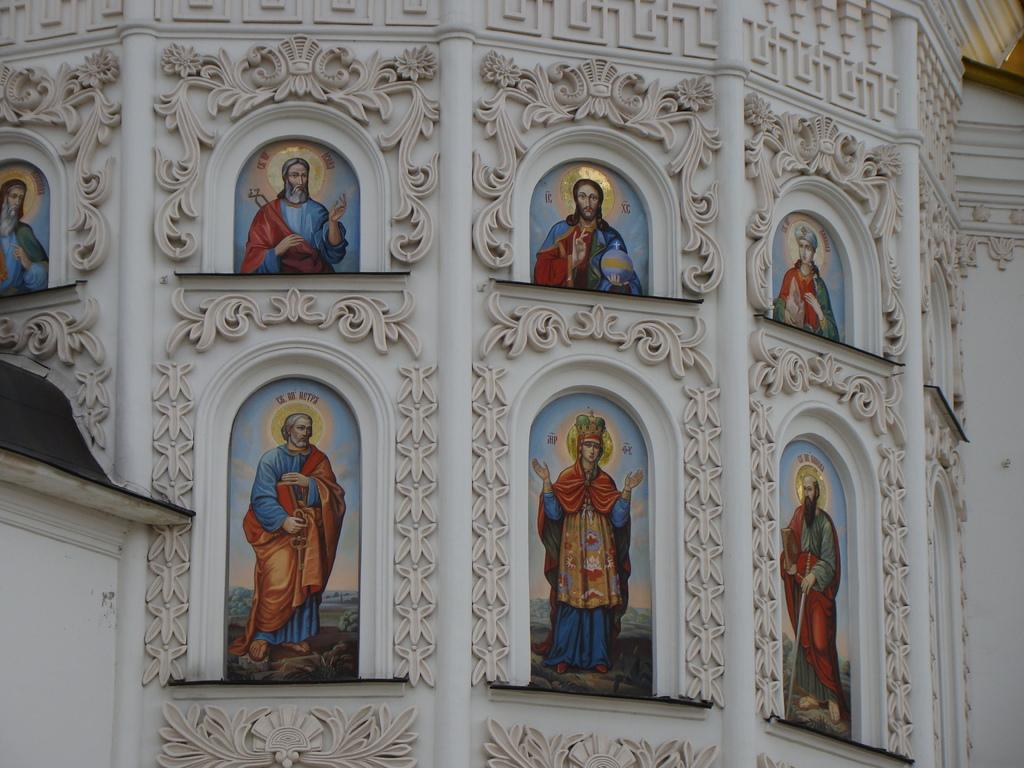What type of images are present in the image? There are photos of a person in the image. Can you describe the subject of the photos? The photos resemble images of lord Jesus. What additional feature can be seen in the image? There is a design carved on the wall in the image. What color is the design on the wall? The design is in white color. What type of powder is being used to clean the scarf in the image? There is no scarf or powder present in the image. How many railway tracks can be seen in the image? There are no railway tracks visible in the image. 